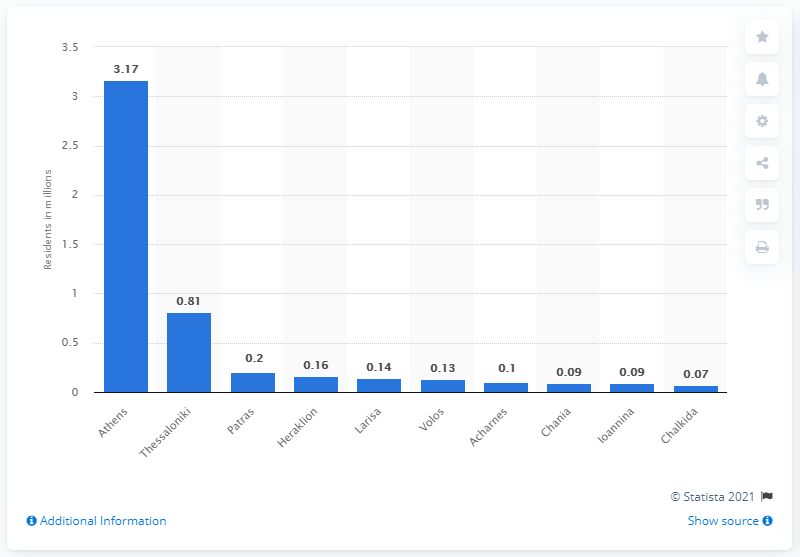Give some essential details in this illustration. In 2011, it is estimated that approximately 3.17 people lived in Athens. The largest city in Greece is Athens. 